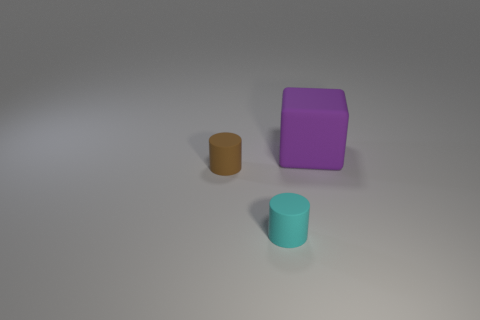Is there anything else that has the same size as the purple matte block?
Your response must be concise. No. Is there anything else that has the same shape as the big thing?
Your answer should be very brief. No. How many large things are either brown objects or yellow metal balls?
Keep it short and to the point. 0. What is the size of the other object that is the same shape as the small brown thing?
Your answer should be compact. Small. How many rubber things are both behind the cyan rubber thing and on the right side of the tiny brown rubber cylinder?
Keep it short and to the point. 1. Does the big purple matte thing have the same shape as the tiny object in front of the small brown cylinder?
Your answer should be very brief. No. Is the number of cyan matte cylinders to the right of the large purple matte thing greater than the number of small gray cylinders?
Offer a terse response. No. Are there fewer small cyan cylinders that are in front of the brown rubber object than gray objects?
Your response must be concise. No. How many large matte cubes are the same color as the big thing?
Provide a succinct answer. 0. There is a object that is both to the right of the tiny brown rubber cylinder and in front of the large rubber cube; what material is it?
Make the answer very short. Rubber. 